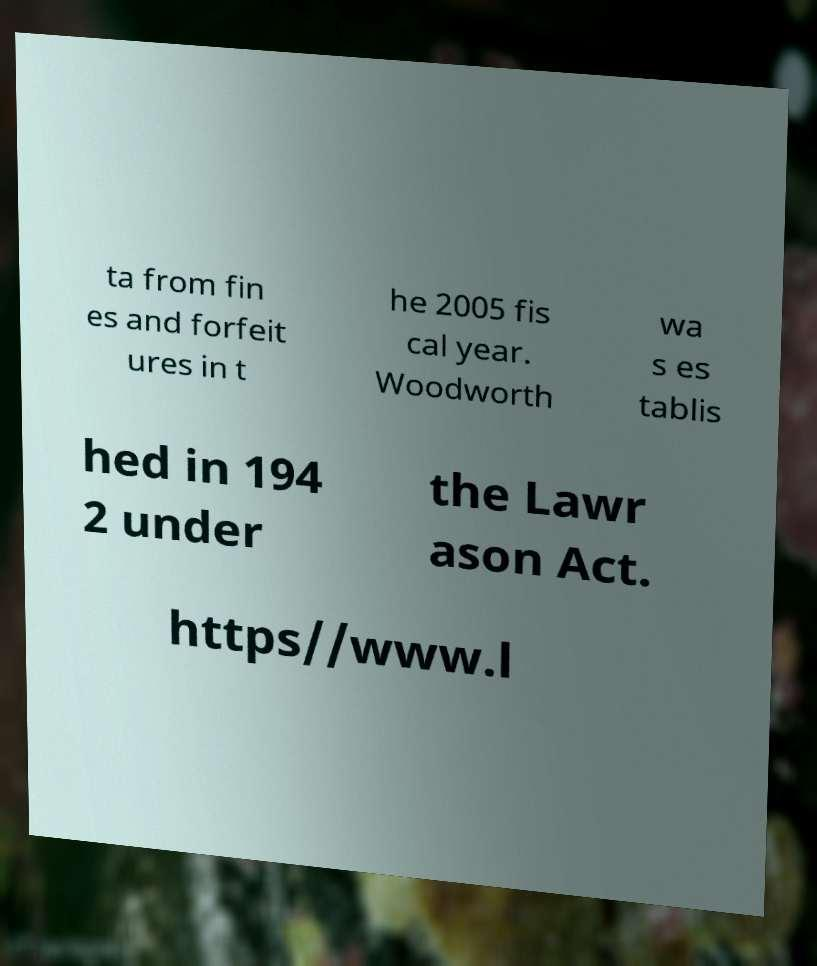Could you assist in decoding the text presented in this image and type it out clearly? ta from fin es and forfeit ures in t he 2005 fis cal year. Woodworth wa s es tablis hed in 194 2 under the Lawr ason Act. https//www.l 